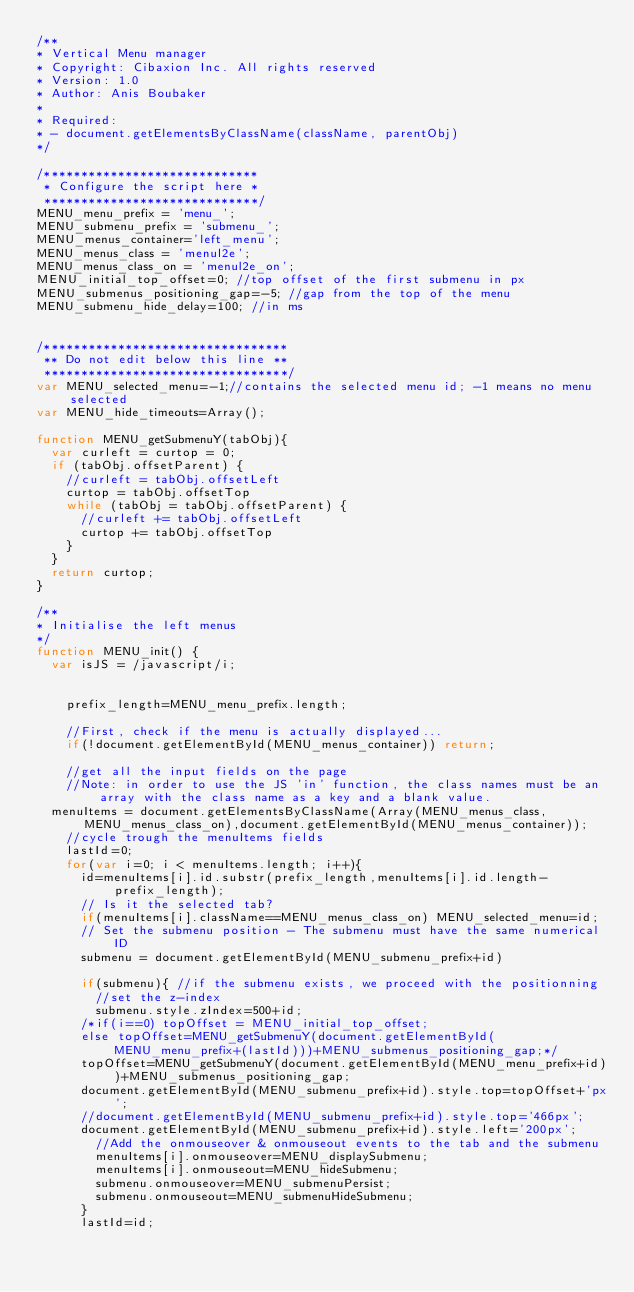Convert code to text. <code><loc_0><loc_0><loc_500><loc_500><_JavaScript_>/**
* Vertical Menu manager
* Copyright: Cibaxion Inc. All rights reserved
* Version: 1.0
* Author: Anis Boubaker
*
* Required:
* - document.getElementsByClassName(className, parentObj)
*/

/*****************************
 * Configure the script here *
 *****************************/
MENU_menu_prefix = 'menu_';
MENU_submenu_prefix = 'submenu_';
MENU_menus_container='left_menu';
MENU_menus_class = 'menul2e';
MENU_menus_class_on = 'menul2e_on';
MENU_initial_top_offset=0; //top offset of the first submenu in px
MENU_submenus_positioning_gap=-5; //gap from the top of the menu
MENU_submenu_hide_delay=100; //in ms


/*********************************
 ** Do not edit below this line **
 *********************************/
var MENU_selected_menu=-1;//contains the selected menu id; -1 means no menu selected
var MENU_hide_timeouts=Array();

function MENU_getSubmenuY(tabObj){
	var curleft = curtop = 0;
	if (tabObj.offsetParent) {
		//curleft = tabObj.offsetLeft
		curtop = tabObj.offsetTop
		while (tabObj = tabObj.offsetParent) {
			//curleft += tabObj.offsetLeft
			curtop += tabObj.offsetTop
		}
	}
	return curtop;
}

/**
* Initialise the left menus
*/
function MENU_init() {
	var isJS = /javascript/i;


    prefix_length=MENU_menu_prefix.length;

    //First, check if the menu is actually displayed...
    if(!document.getElementById(MENU_menus_container)) return;

    //get all the input fields on the page
    //Note: in order to use the JS 'in' function, the class names must be an array with the class name as a key and a blank value.
	menuItems = document.getElementsByClassName(Array(MENU_menus_class,MENU_menus_class_on),document.getElementById(MENU_menus_container));
    //cycle trough the menuItems fields
    lastId=0;
    for(var i=0; i < menuItems.length; i++){
    	id=menuItems[i].id.substr(prefix_length,menuItems[i].id.length-prefix_length);
    	// Is it the selected tab?
    	if(menuItems[i].className==MENU_menus_class_on) MENU_selected_menu=id;
    	// Set the submenu position - The submenu must have the same numerical ID
    	submenu = document.getElementById(MENU_submenu_prefix+id)

    	if(submenu){ //if the submenu exists, we proceed with the positionning
    		//set the z-index
    		submenu.style.zIndex=500+id;
			/*if(i==0) topOffset = MENU_initial_top_offset;
			else topOffset=MENU_getSubmenuY(document.getElementById(MENU_menu_prefix+(lastId)))+MENU_submenus_positioning_gap;*/
			topOffset=MENU_getSubmenuY(document.getElementById(MENU_menu_prefix+id))+MENU_submenus_positioning_gap;
			document.getElementById(MENU_submenu_prefix+id).style.top=topOffset+'px';
			//document.getElementById(MENU_submenu_prefix+id).style.top='466px';
			document.getElementById(MENU_submenu_prefix+id).style.left='200px';
	    	//Add the onmouseover & onmouseout events to the tab and the submenu
	    	menuItems[i].onmouseover=MENU_displaySubmenu;
	    	menuItems[i].onmouseout=MENU_hideSubmenu;
	    	submenu.onmouseover=MENU_submenuPersist;
	    	submenu.onmouseout=MENU_submenuHideSubmenu;
    	}
    	lastId=id;</code> 